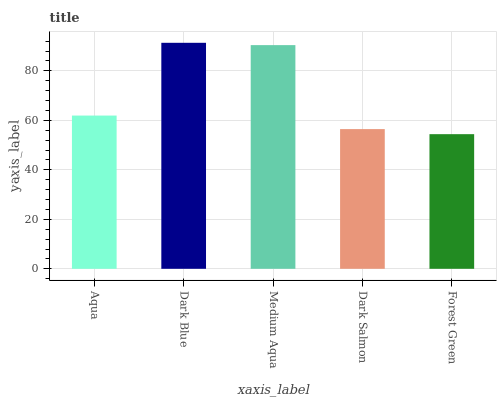Is Forest Green the minimum?
Answer yes or no. Yes. Is Dark Blue the maximum?
Answer yes or no. Yes. Is Medium Aqua the minimum?
Answer yes or no. No. Is Medium Aqua the maximum?
Answer yes or no. No. Is Dark Blue greater than Medium Aqua?
Answer yes or no. Yes. Is Medium Aqua less than Dark Blue?
Answer yes or no. Yes. Is Medium Aqua greater than Dark Blue?
Answer yes or no. No. Is Dark Blue less than Medium Aqua?
Answer yes or no. No. Is Aqua the high median?
Answer yes or no. Yes. Is Aqua the low median?
Answer yes or no. Yes. Is Forest Green the high median?
Answer yes or no. No. Is Dark Salmon the low median?
Answer yes or no. No. 